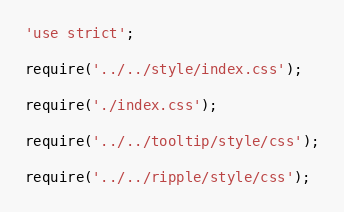<code> <loc_0><loc_0><loc_500><loc_500><_JavaScript_>'use strict';

require('../../style/index.css');

require('./index.css');

require('../../tooltip/style/css');

require('../../ripple/style/css');</code> 